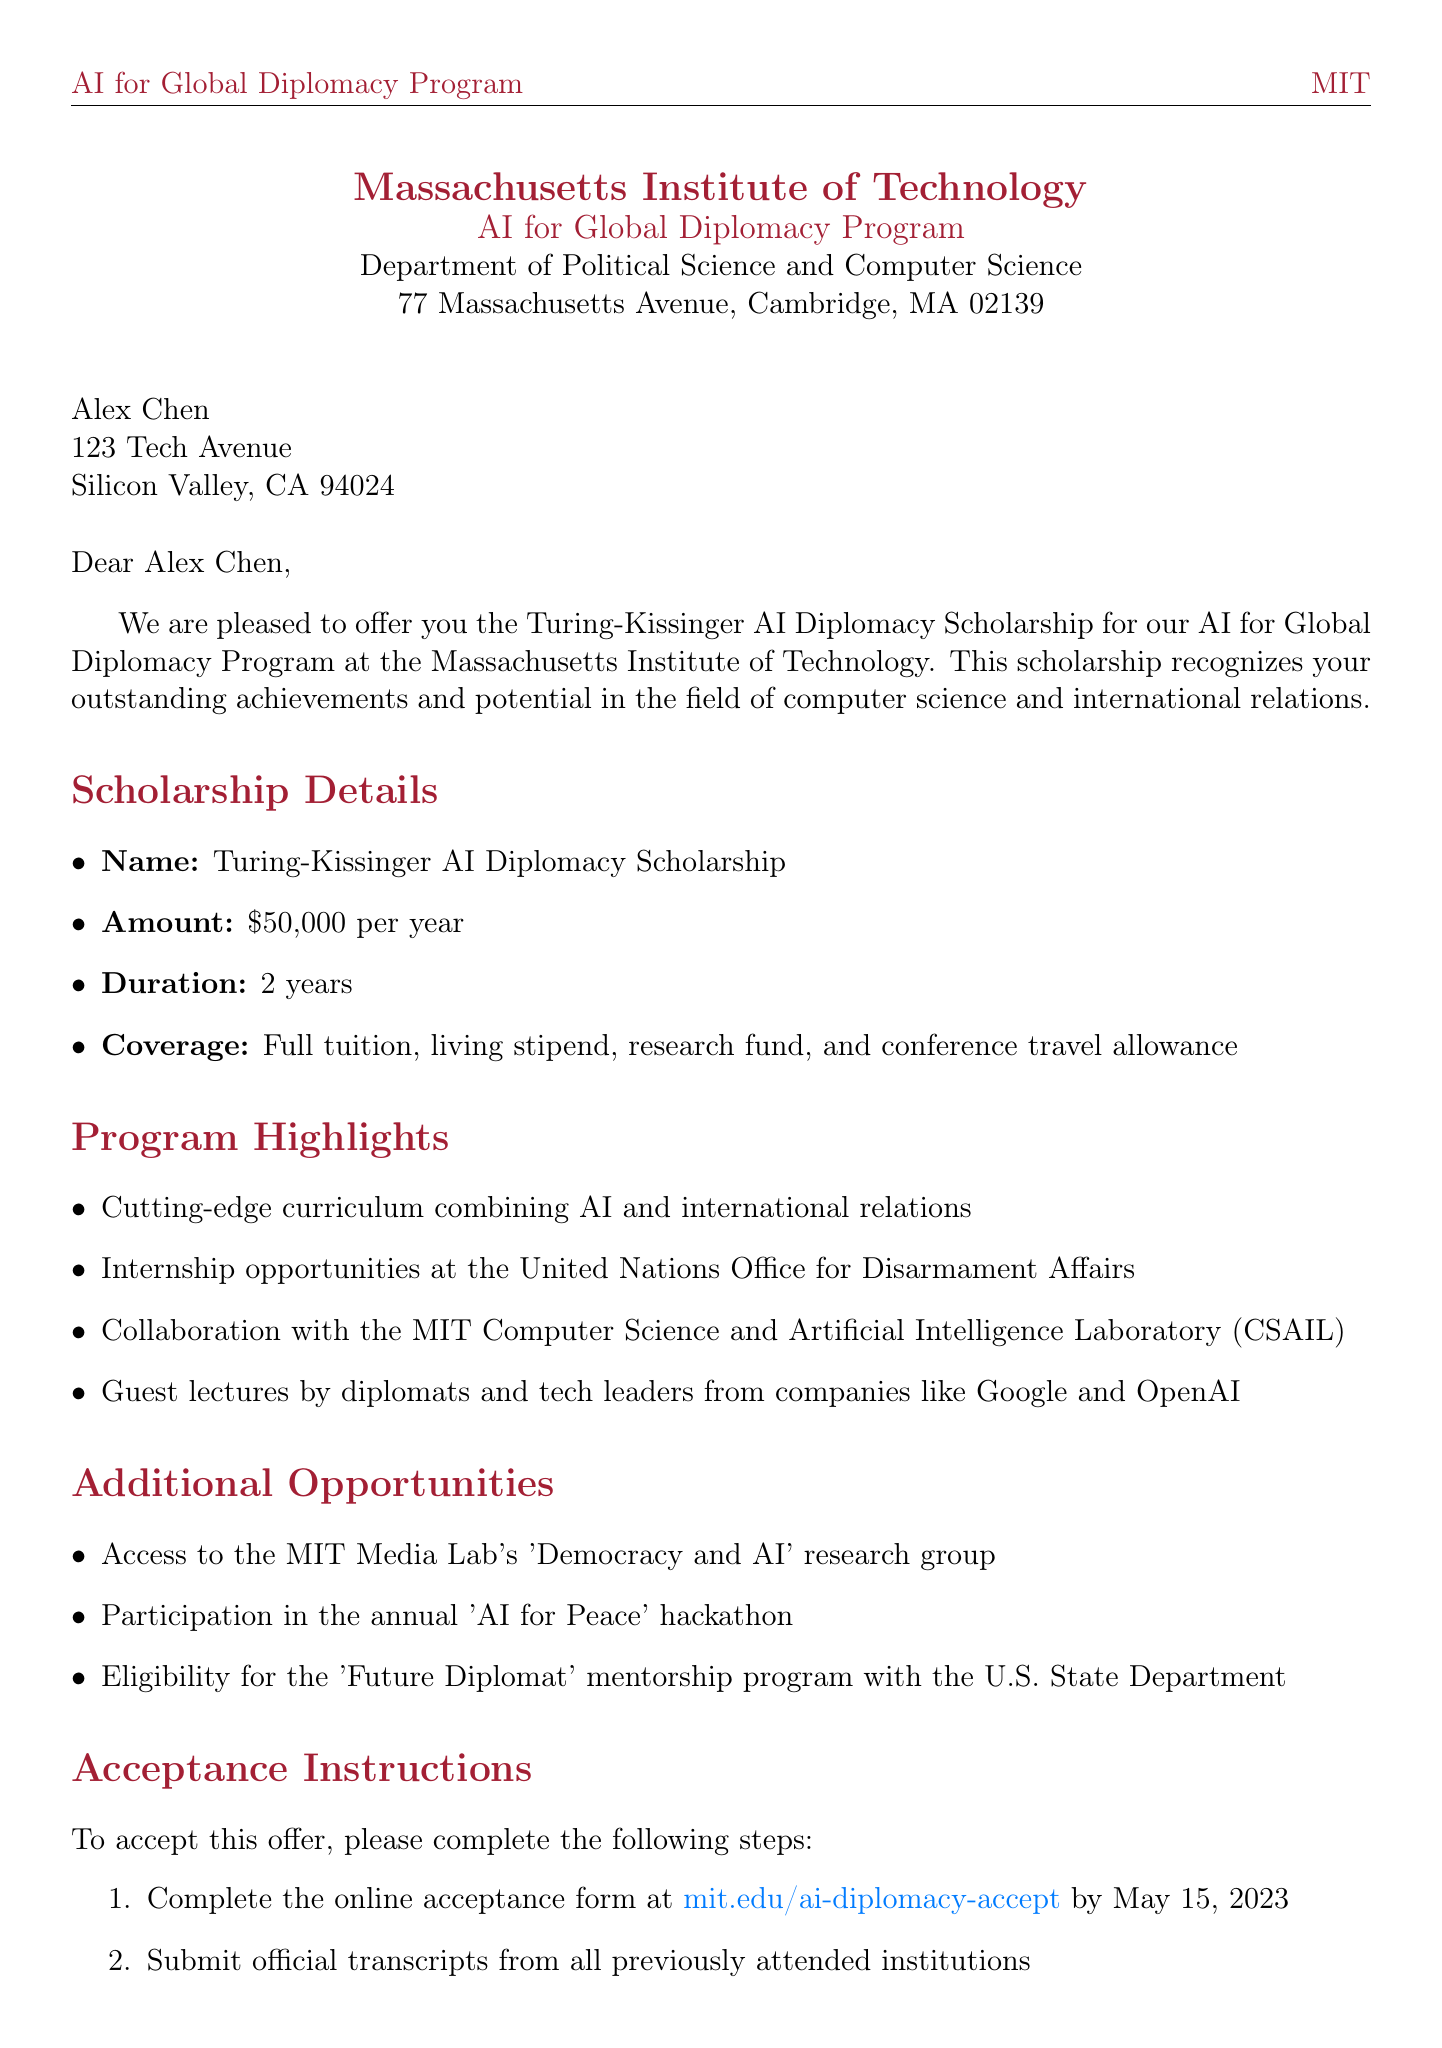What is the name of the scholarship? The name of the scholarship is stated in the letter as Turing-Kissinger AI Diplomacy Scholarship.
Answer: Turing-Kissinger AI Diplomacy Scholarship What is the scholarship amount? The letter specifies the scholarship amount as $50,000 per year.
Answer: $50,000 per year What is the duration of the scholarship? The duration of the scholarship is mentioned as 2 years in the document.
Answer: 2 years When is the acceptance deadline? The letter lists the acceptance deadline as May 15, 2023.
Answer: May 15, 2023 Who is the program director? The document provides the name of the program director as Dr. Sarah Goldstein.
Answer: Dr. Sarah Goldstein What is one internship opportunity mentioned in the letter? The letter mentions an internship opportunity at the United Nations Office for Disarmament Affairs.
Answer: United Nations Office for Disarmament Affairs What must be submitted by the acceptance deadline? The letter indicates that official transcripts from all previously attended institutions must be submitted.
Answer: Official transcripts What is the date of the mandatory orientation session? The letter states that the orientation session is on August 25, 2023.
Answer: August 25, 2023 What is one of the additional opportunities provided by the program? The letter states access to the MIT Media Lab's 'Democracy and AI' research group as an additional opportunity.
Answer: MIT Media Lab's 'Democracy and AI' research group 